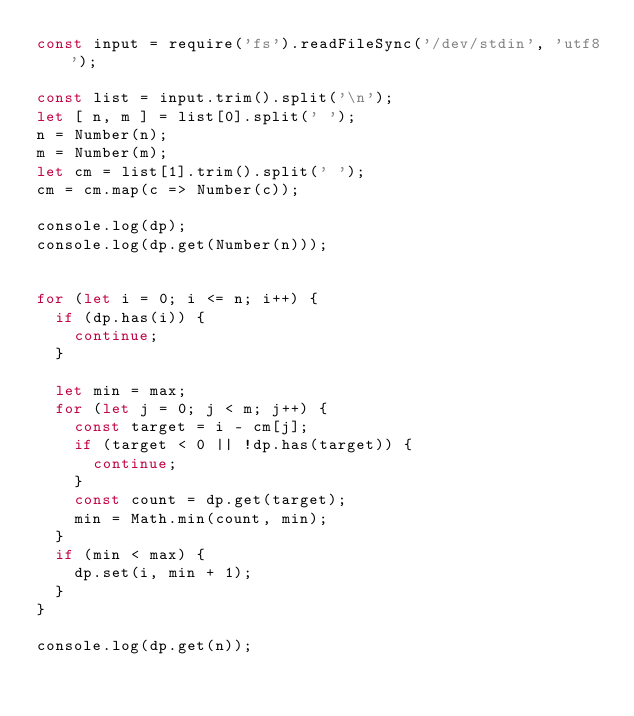Convert code to text. <code><loc_0><loc_0><loc_500><loc_500><_JavaScript_>const input = require('fs').readFileSync('/dev/stdin', 'utf8');

const list = input.trim().split('\n');
let [ n, m ] = list[0].split(' ');
n = Number(n);
m = Number(m);
let cm = list[1].trim().split(' ');
cm = cm.map(c => Number(c));

console.log(dp);
console.log(dp.get(Number(n)));


for (let i = 0; i <= n; i++) {
  if (dp.has(i)) {
    continue;
  }

  let min = max;
  for (let j = 0; j < m; j++) {
    const target = i - cm[j];
    if (target < 0 || !dp.has(target)) {
      continue;
    }
    const count = dp.get(target);
    min = Math.min(count, min);
  }
  if (min < max) {
    dp.set(i, min + 1);
  }
}

console.log(dp.get(n));

</code> 